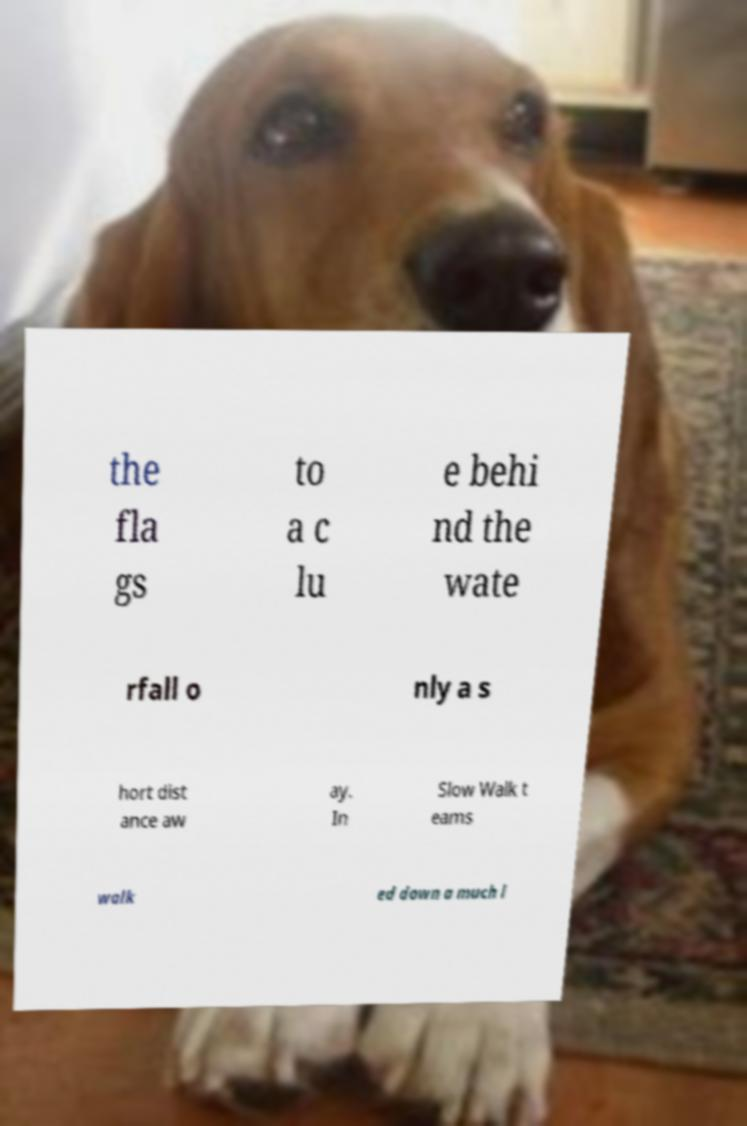There's text embedded in this image that I need extracted. Can you transcribe it verbatim? the fla gs to a c lu e behi nd the wate rfall o nly a s hort dist ance aw ay. In Slow Walk t eams walk ed down a much l 